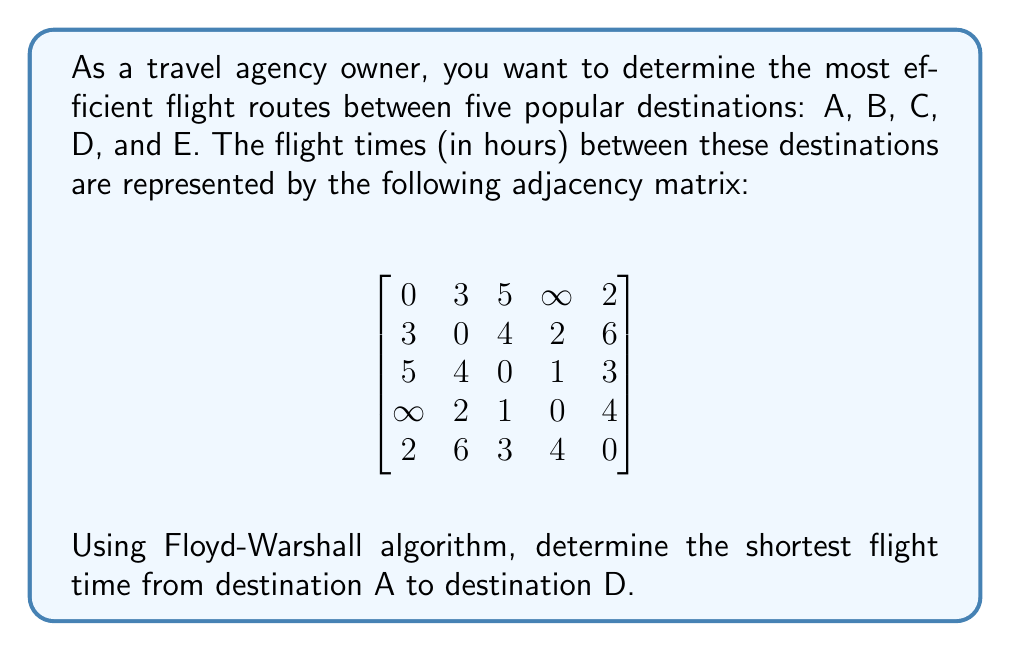What is the answer to this math problem? To solve this problem, we'll use the Floyd-Warshall algorithm, which is an efficient method for finding the shortest paths between all pairs of vertices in a weighted graph. This algorithm is particularly useful for travel networks where we need to determine optimal routes.

Step 1: Initialize the distance matrix D with the given adjacency matrix.

Step 2: Apply the Floyd-Warshall algorithm:
For k = 1 to 5:
    For i = 1 to 5:
        For j = 1 to 5:
            $D[i][j] = min(D[i][j], D[i][k] + D[k][j])$

Step 3: Update the matrix for each intermediate vertex (k):

For k = 1 (A):
No changes, as A is already directly connected to all reachable vertices.

For k = 2 (B):
$D[A][D] = min(D[A][D], D[A][B] + D[B][D]) = min(\infty, 3 + 2) = 5$

For k = 3 (C):
$D[A][D] = min(D[A][D], D[A][C] + D[C][D]) = min(5, 5 + 1) = 5$

For k = 4 (D):
No changes, as we've already found the shortest path to D.

For k = 5 (E):
$D[A][D] = min(D[A][D], D[A][E] + D[E][D]) = min(5, 2 + 4) = 5$

After applying the Floyd-Warshall algorithm, the shortest flight time from A to D remains 5 hours.

The optimal route is either A -> B -> D or A -> C -> D, both taking 5 hours.
Answer: The shortest flight time from destination A to destination D is 5 hours. 